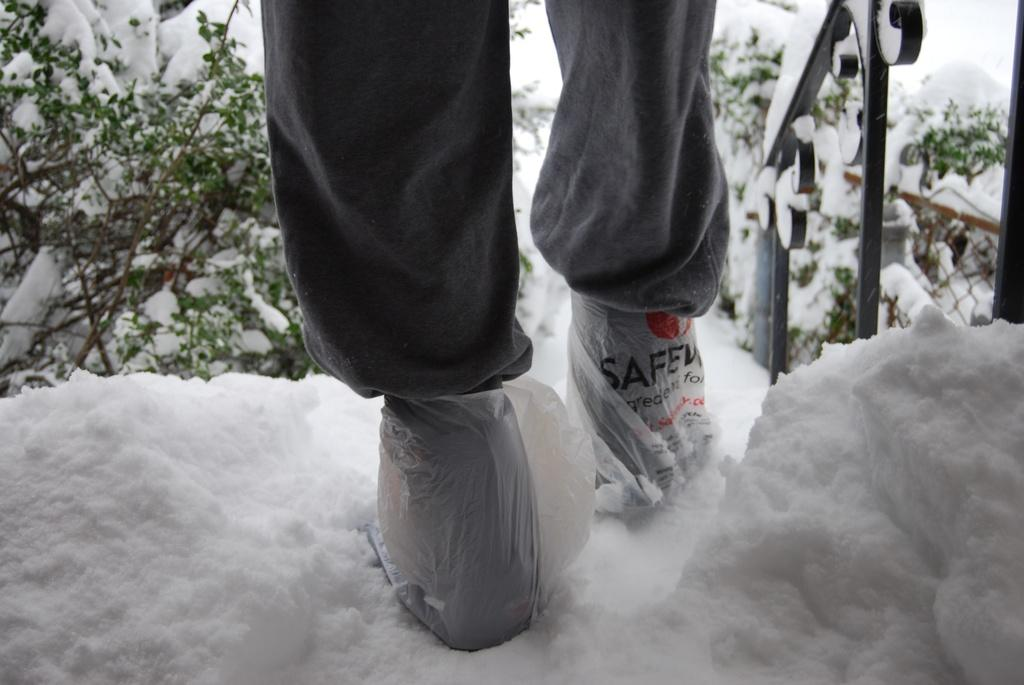What is visible in the image related to a person? There are legs of a person in the snow. What type of natural environment is depicted in the image? The image shows a snowy environment. What else can be seen in the image besides the person's legs? There are trees in the image. What type of apparel is the person wearing to expand the thing in the image? There is no information about the person's apparel or any expansion in the image. 